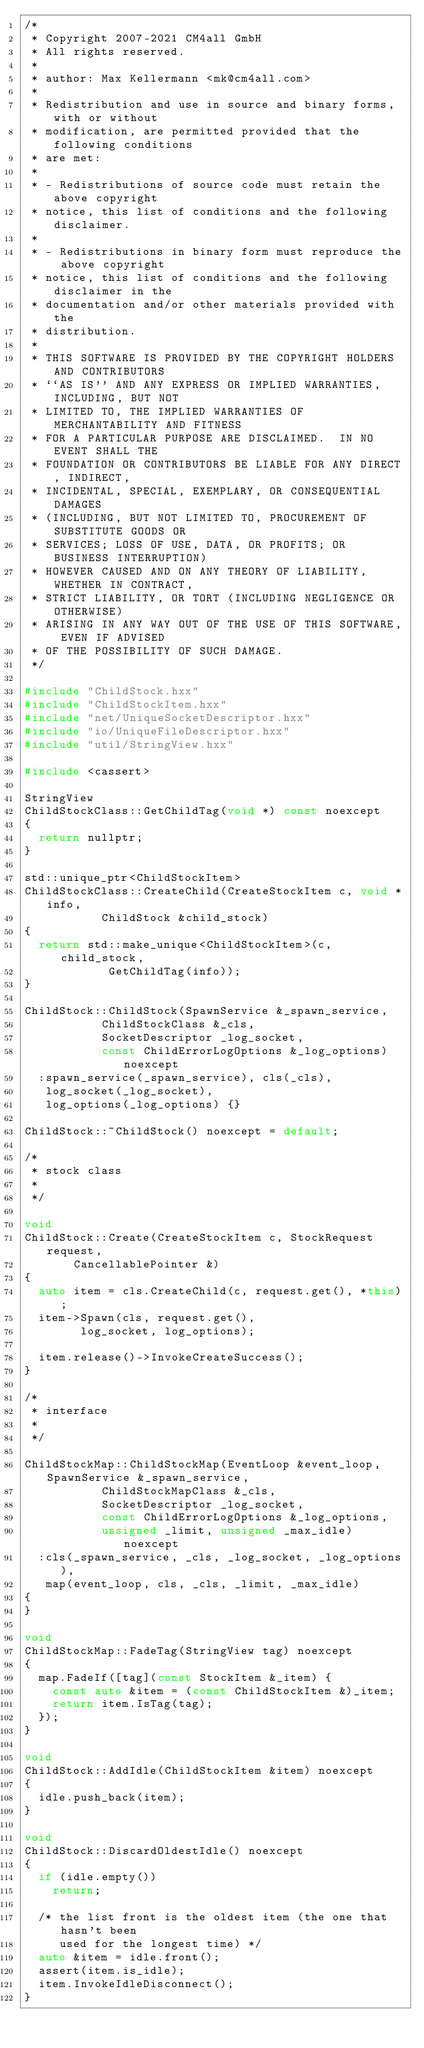Convert code to text. <code><loc_0><loc_0><loc_500><loc_500><_C++_>/*
 * Copyright 2007-2021 CM4all GmbH
 * All rights reserved.
 *
 * author: Max Kellermann <mk@cm4all.com>
 *
 * Redistribution and use in source and binary forms, with or without
 * modification, are permitted provided that the following conditions
 * are met:
 *
 * - Redistributions of source code must retain the above copyright
 * notice, this list of conditions and the following disclaimer.
 *
 * - Redistributions in binary form must reproduce the above copyright
 * notice, this list of conditions and the following disclaimer in the
 * documentation and/or other materials provided with the
 * distribution.
 *
 * THIS SOFTWARE IS PROVIDED BY THE COPYRIGHT HOLDERS AND CONTRIBUTORS
 * ``AS IS'' AND ANY EXPRESS OR IMPLIED WARRANTIES, INCLUDING, BUT NOT
 * LIMITED TO, THE IMPLIED WARRANTIES OF MERCHANTABILITY AND FITNESS
 * FOR A PARTICULAR PURPOSE ARE DISCLAIMED.  IN NO EVENT SHALL THE
 * FOUNDATION OR CONTRIBUTORS BE LIABLE FOR ANY DIRECT, INDIRECT,
 * INCIDENTAL, SPECIAL, EXEMPLARY, OR CONSEQUENTIAL DAMAGES
 * (INCLUDING, BUT NOT LIMITED TO, PROCUREMENT OF SUBSTITUTE GOODS OR
 * SERVICES; LOSS OF USE, DATA, OR PROFITS; OR BUSINESS INTERRUPTION)
 * HOWEVER CAUSED AND ON ANY THEORY OF LIABILITY, WHETHER IN CONTRACT,
 * STRICT LIABILITY, OR TORT (INCLUDING NEGLIGENCE OR OTHERWISE)
 * ARISING IN ANY WAY OUT OF THE USE OF THIS SOFTWARE, EVEN IF ADVISED
 * OF THE POSSIBILITY OF SUCH DAMAGE.
 */

#include "ChildStock.hxx"
#include "ChildStockItem.hxx"
#include "net/UniqueSocketDescriptor.hxx"
#include "io/UniqueFileDescriptor.hxx"
#include "util/StringView.hxx"

#include <cassert>

StringView
ChildStockClass::GetChildTag(void *) const noexcept
{
	return nullptr;
}

std::unique_ptr<ChildStockItem>
ChildStockClass::CreateChild(CreateStockItem c, void *info,
			     ChildStock &child_stock)
{
	return std::make_unique<ChildStockItem>(c, child_stock,
						GetChildTag(info));
}

ChildStock::ChildStock(SpawnService &_spawn_service,
		       ChildStockClass &_cls,
		       SocketDescriptor _log_socket,
		       const ChildErrorLogOptions &_log_options) noexcept
	:spawn_service(_spawn_service), cls(_cls),
	 log_socket(_log_socket),
	 log_options(_log_options) {}

ChildStock::~ChildStock() noexcept = default;

/*
 * stock class
 *
 */

void
ChildStock::Create(CreateStockItem c, StockRequest request,
		   CancellablePointer &)
{
	auto item = cls.CreateChild(c, request.get(), *this);
	item->Spawn(cls, request.get(),
		    log_socket, log_options);

	item.release()->InvokeCreateSuccess();
}

/*
 * interface
 *
 */

ChildStockMap::ChildStockMap(EventLoop &event_loop, SpawnService &_spawn_service,
			     ChildStockMapClass &_cls,
			     SocketDescriptor _log_socket,
			     const ChildErrorLogOptions &_log_options,
			     unsigned _limit, unsigned _max_idle) noexcept
	:cls(_spawn_service, _cls, _log_socket, _log_options),
	 map(event_loop, cls, _cls, _limit, _max_idle)
{
}

void
ChildStockMap::FadeTag(StringView tag) noexcept
{
	map.FadeIf([tag](const StockItem &_item) {
		const auto &item = (const ChildStockItem &)_item;
		return item.IsTag(tag);
	});
}

void
ChildStock::AddIdle(ChildStockItem &item) noexcept
{
	idle.push_back(item);
}

void
ChildStock::DiscardOldestIdle() noexcept
{
	if (idle.empty())
		return;

	/* the list front is the oldest item (the one that hasn't been
	   used for the longest time) */
	auto &item = idle.front();
	assert(item.is_idle);
	item.InvokeIdleDisconnect();
}
</code> 